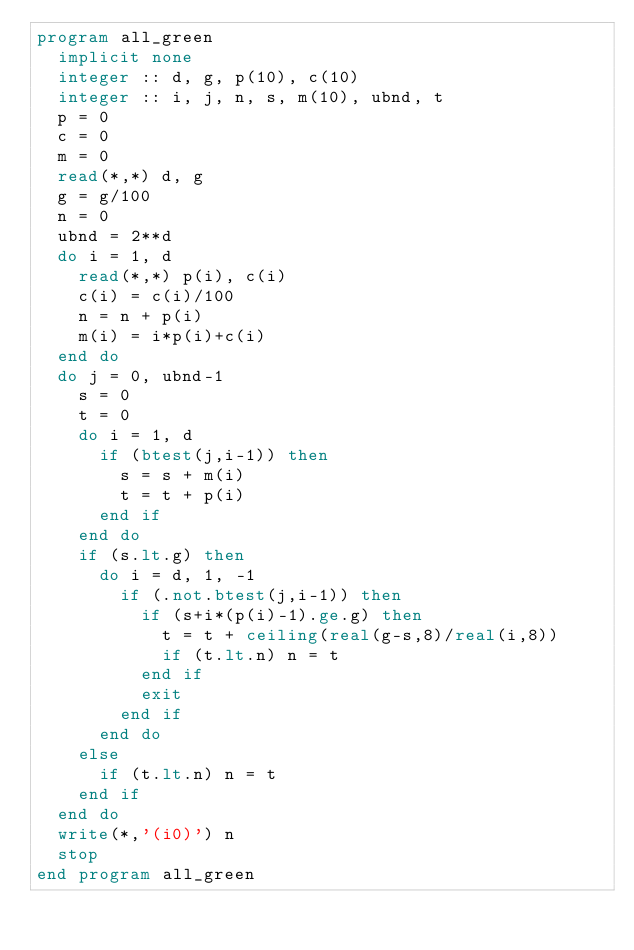Convert code to text. <code><loc_0><loc_0><loc_500><loc_500><_FORTRAN_>program all_green
  implicit none
  integer :: d, g, p(10), c(10)
  integer :: i, j, n, s, m(10), ubnd, t
  p = 0
  c = 0
  m = 0
  read(*,*) d, g
  g = g/100
  n = 0
  ubnd = 2**d
  do i = 1, d
    read(*,*) p(i), c(i)
    c(i) = c(i)/100
    n = n + p(i)
    m(i) = i*p(i)+c(i)
  end do
  do j = 0, ubnd-1
    s = 0
    t = 0
    do i = 1, d
      if (btest(j,i-1)) then
        s = s + m(i)
        t = t + p(i)
      end if
    end do
    if (s.lt.g) then
      do i = d, 1, -1
        if (.not.btest(j,i-1)) then
          if (s+i*(p(i)-1).ge.g) then
            t = t + ceiling(real(g-s,8)/real(i,8))
            if (t.lt.n) n = t
          end if
          exit
        end if
      end do
    else
      if (t.lt.n) n = t
    end if
  end do
  write(*,'(i0)') n
  stop
end program all_green</code> 